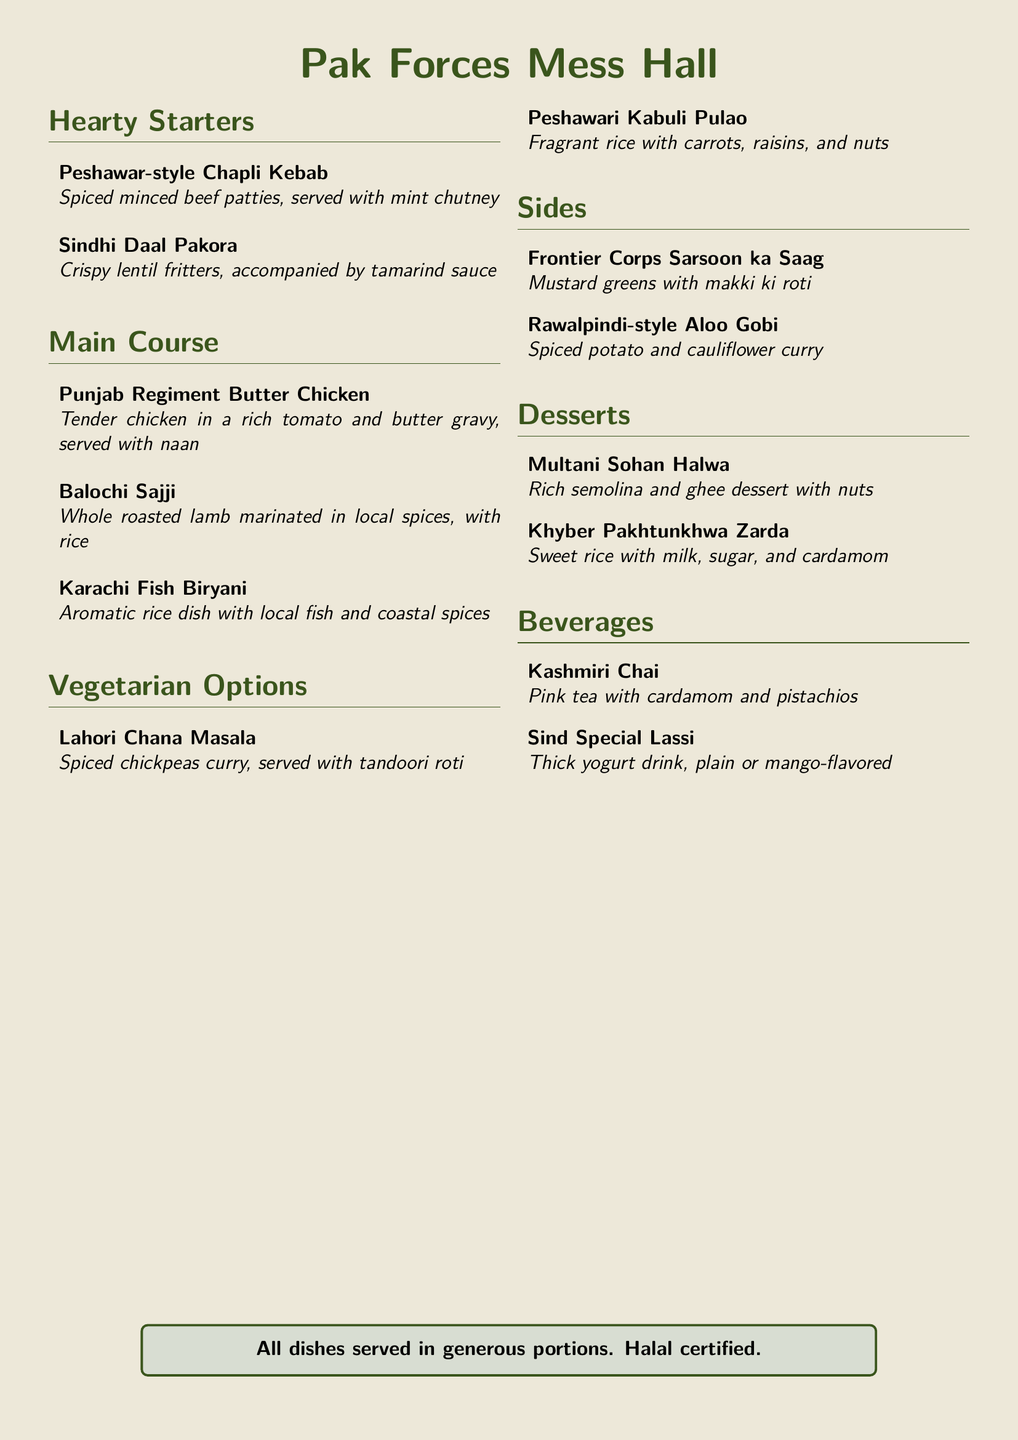What are the starters available? The starters listed in the menu are under the section "Hearty Starters."
Answer: Peshawar-style Chapli Kebab, Sindhi Daal Pakora What is the main ingredient in Punjab Regiment Butter Chicken? The main ingredient in Punjab Regiment Butter Chicken is tender chicken.
Answer: Tender chicken Which dessert contains semolina and ghee? The dessert that contains semolina and ghee is listed under the "Desserts" section.
Answer: Multani Sohan Halwa What beverage is pink in color? The beverage that is pink in color is mentioned in the "Beverages" section of the menu.
Answer: Kashmiri Chai How many vegetarian options are listed? To find the number of vegetarian options, we count the items in the "Vegetarian Options" section.
Answer: 2 What type of meat is used in Balochi Sajji? The type of meat used in Balochi Sajji is whole roasted lamb.
Answer: Whole roasted lamb What is served with Frontier Corps Sarsoon ka Saag? To find the accompaniment, refer to the "Sides" section where it is mentioned.
Answer: Makki ki roti Which dish is fragrant and includes nuts? This dish is found in the "Vegetarian Options" section, indicating its characteristics.
Answer: Peshawari Kabuli Pulao 